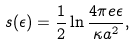Convert formula to latex. <formula><loc_0><loc_0><loc_500><loc_500>s ( \epsilon ) = \frac { 1 } { 2 } \ln \frac { 4 \pi e \epsilon } { \kappa a ^ { 2 } } ,</formula> 